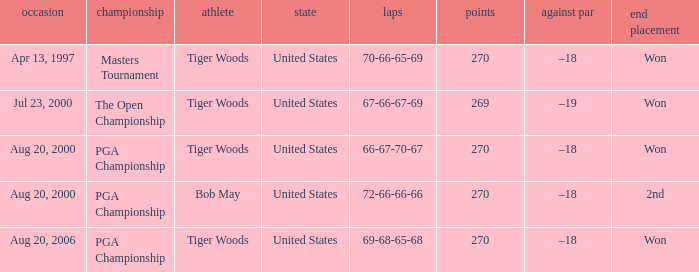What players finished 2nd? Bob May. 